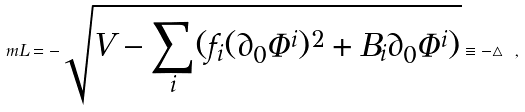Convert formula to latex. <formula><loc_0><loc_0><loc_500><loc_500>\ m L = - \sqrt { V - \sum _ { i } ( f _ { i } ( \partial _ { 0 } { \Phi } ^ { i } ) ^ { 2 } + B _ { i } \partial _ { 0 } \Phi ^ { i } ) } \equiv - \triangle \ ,</formula> 